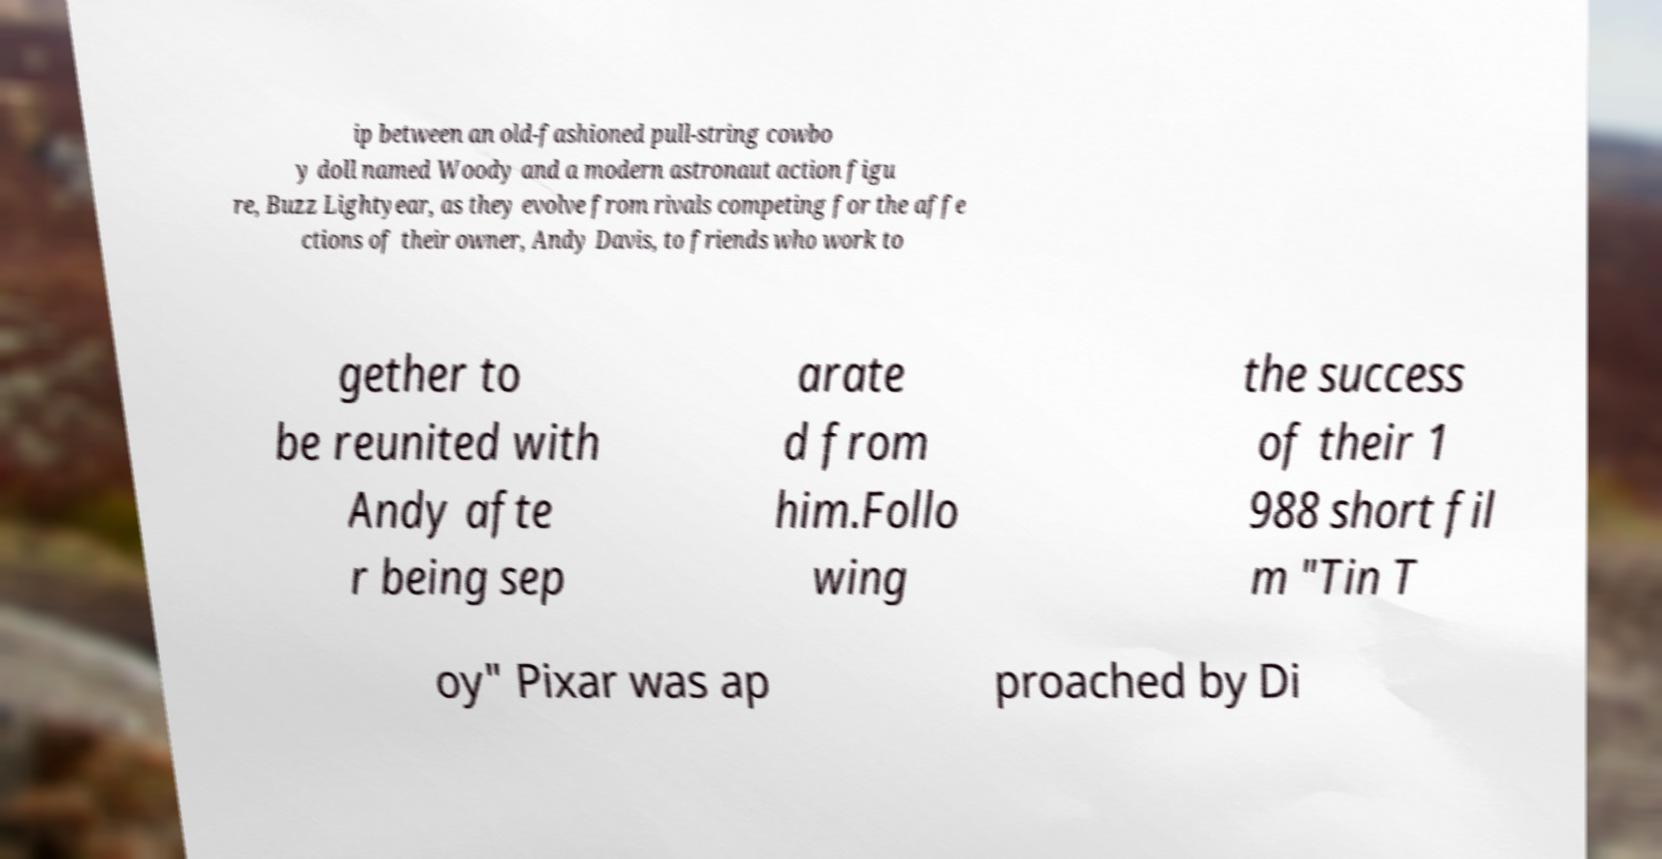I need the written content from this picture converted into text. Can you do that? ip between an old-fashioned pull-string cowbo y doll named Woody and a modern astronaut action figu re, Buzz Lightyear, as they evolve from rivals competing for the affe ctions of their owner, Andy Davis, to friends who work to gether to be reunited with Andy afte r being sep arate d from him.Follo wing the success of their 1 988 short fil m "Tin T oy" Pixar was ap proached by Di 